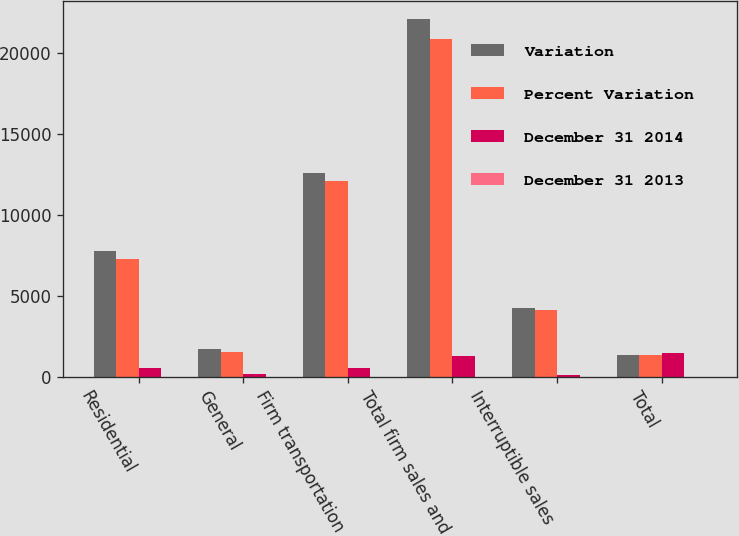Convert chart to OTSL. <chart><loc_0><loc_0><loc_500><loc_500><stacked_bar_chart><ecel><fcel>Residential<fcel>General<fcel>Firm transportation<fcel>Total firm sales and<fcel>Interruptible sales<fcel>Total<nl><fcel>Variation<fcel>7786<fcel>1743<fcel>12592<fcel>22121<fcel>4216<fcel>1355.5<nl><fcel>Percent Variation<fcel>7253<fcel>1555<fcel>12062<fcel>20870<fcel>4118<fcel>1355.5<nl><fcel>December 31 2014<fcel>533<fcel>188<fcel>530<fcel>1251<fcel>98<fcel>1460<nl><fcel>December 31 2013<fcel>7.3<fcel>12.1<fcel>4.4<fcel>6<fcel>2.4<fcel>5.6<nl></chart> 